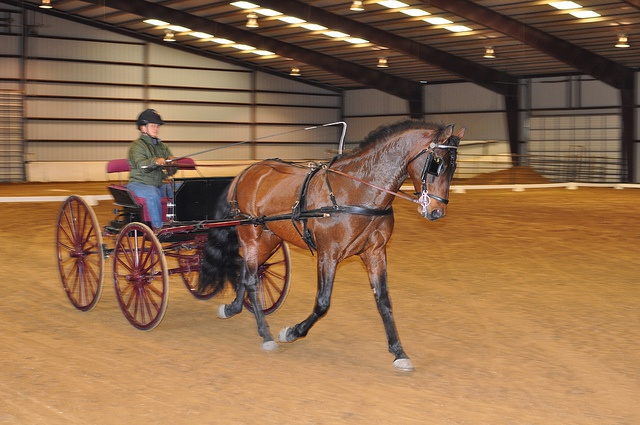Describe the objects in this image and their specific colors. I can see horse in black, gray, and brown tones and people in black and gray tones in this image. 